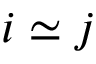Convert formula to latex. <formula><loc_0><loc_0><loc_500><loc_500>i \simeq j</formula> 